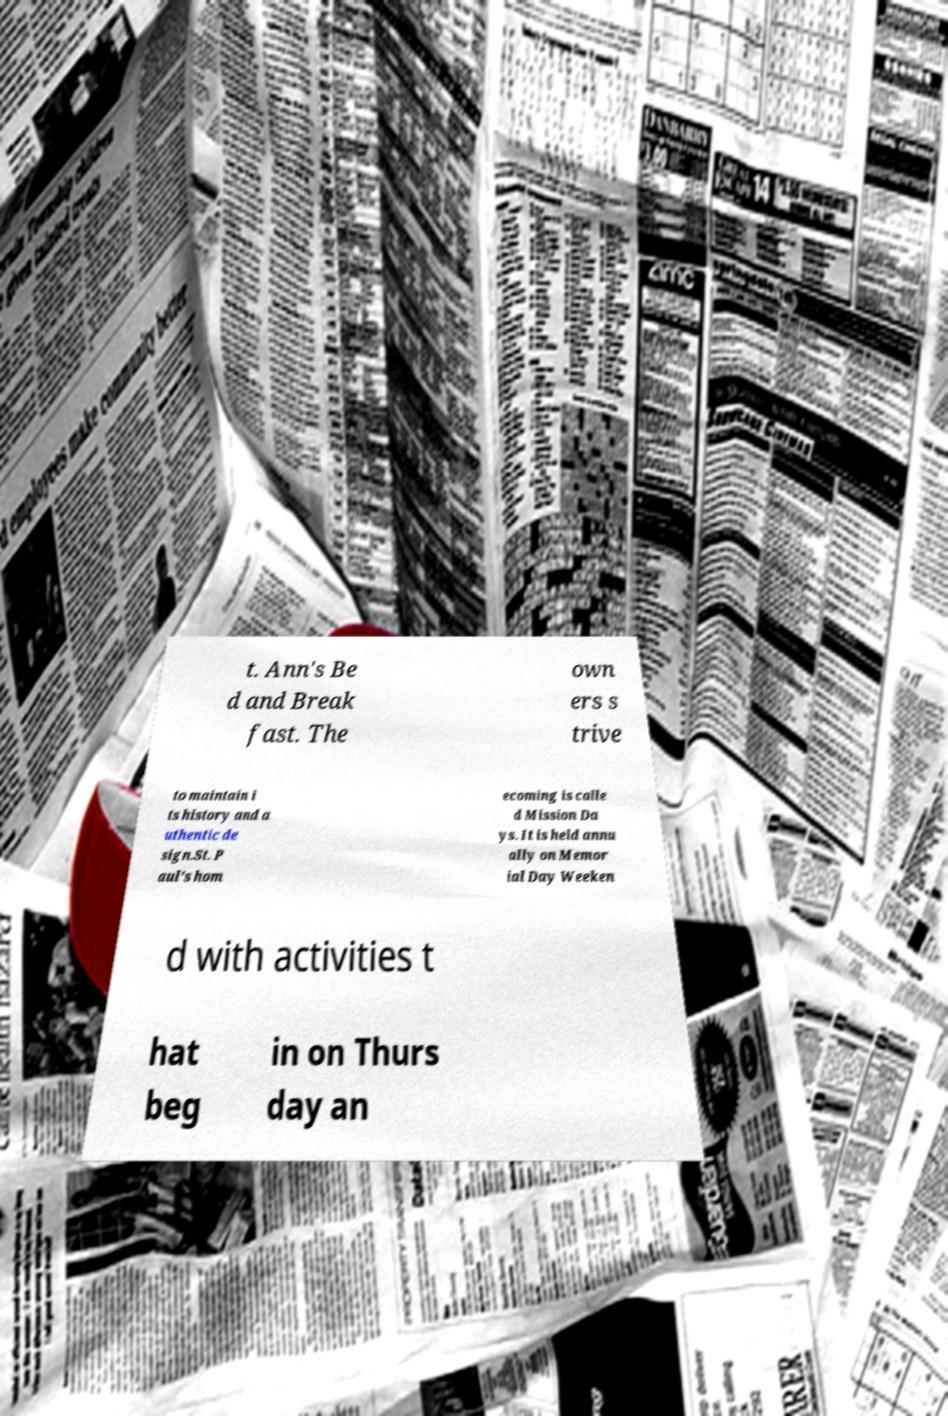There's text embedded in this image that I need extracted. Can you transcribe it verbatim? t. Ann's Be d and Break fast. The own ers s trive to maintain i ts history and a uthentic de sign.St. P aul's hom ecoming is calle d Mission Da ys. It is held annu ally on Memor ial Day Weeken d with activities t hat beg in on Thurs day an 